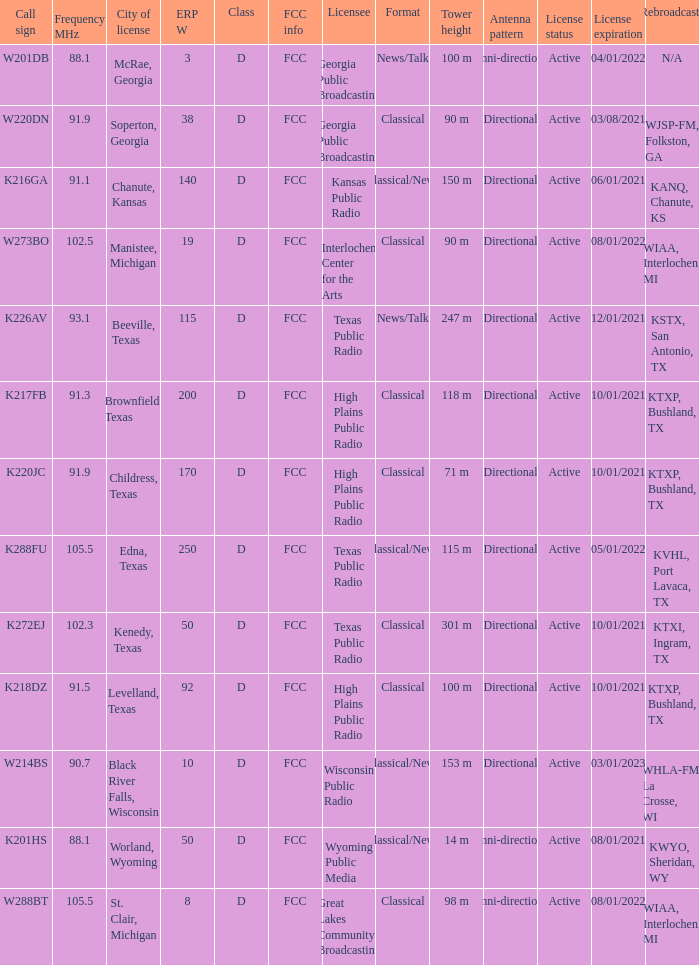What is Call Sign, when ERP W is greater than 50? K216GA, K226AV, K217FB, K220JC, K288FU, K218DZ. 